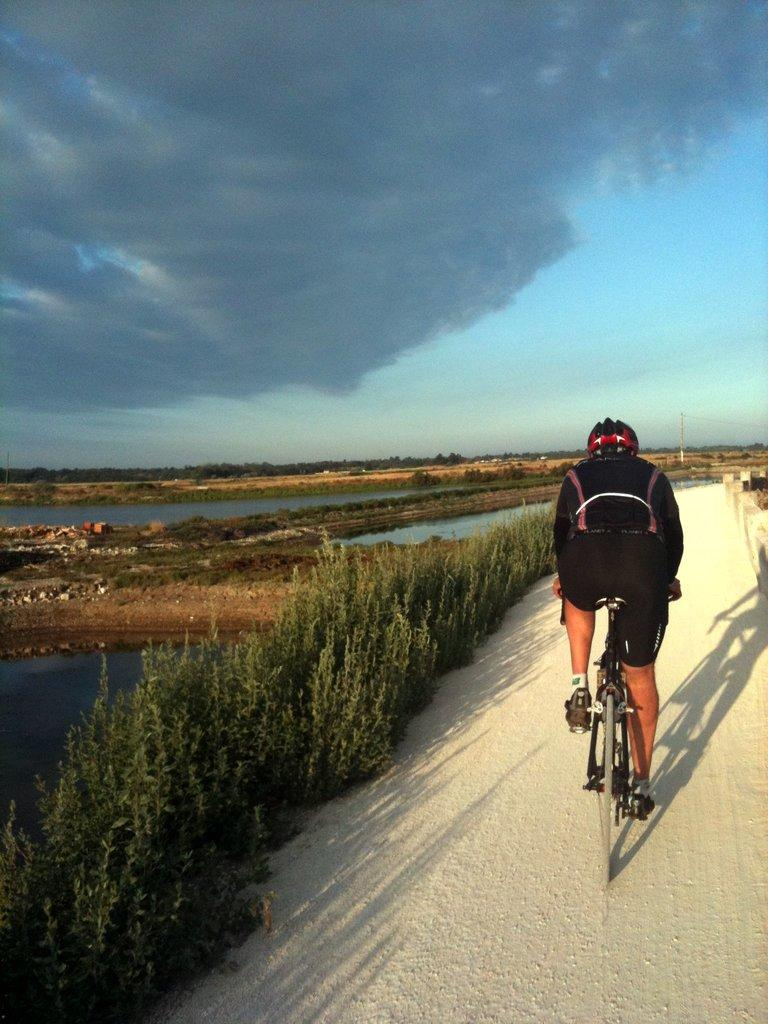What is the person in the image doing? There is a person riding a bicycle in the image. What can be seen in the background of the image? There is water, plants, trees, and the sky visible in the image. What is the condition of the sky in the image? The sky is visible in the image, and it contains clouds. How many cats are sitting quietly on the bicycle in the image? There are no cats present in the image, and the person is riding the bicycle, not sitting quietly. 